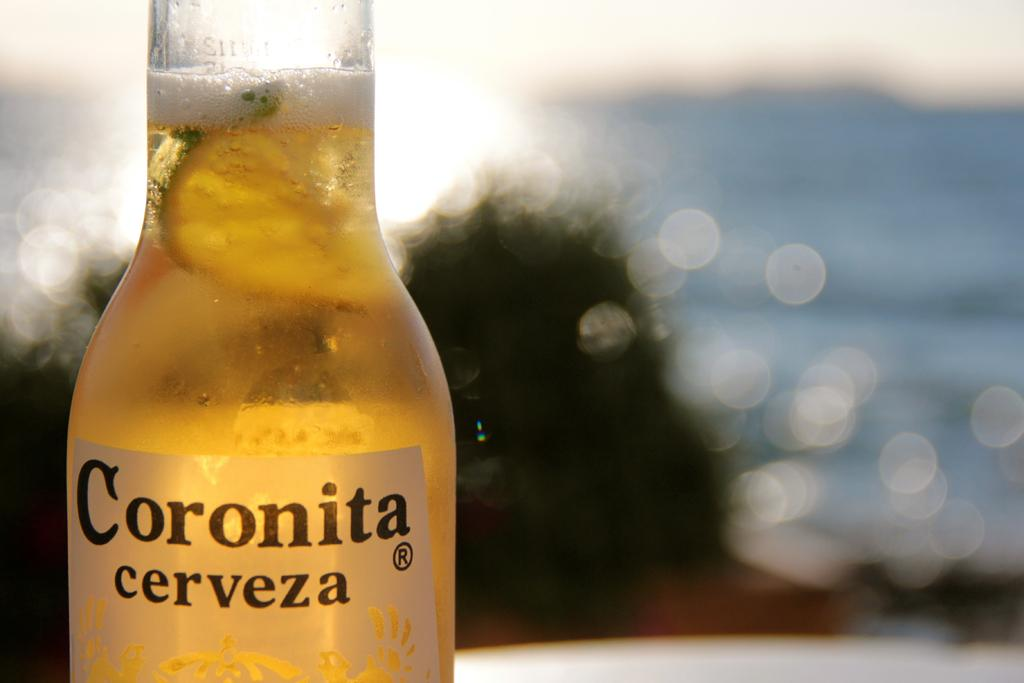<image>
Describe the image concisely. A bottle Coronita is in the foreground of a body of water. 